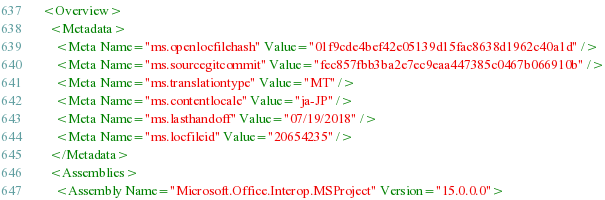<code> <loc_0><loc_0><loc_500><loc_500><_XML_><Overview>
  <Metadata>
    <Meta Name="ms.openlocfilehash" Value="01f9cde4bef42e05139d15fac8638d1962c40a1d" />
    <Meta Name="ms.sourcegitcommit" Value="fec857fbb3ba2e7ec9eaa447385c0467b066910b" />
    <Meta Name="ms.translationtype" Value="MT" />
    <Meta Name="ms.contentlocale" Value="ja-JP" />
    <Meta Name="ms.lasthandoff" Value="07/19/2018" />
    <Meta Name="ms.locfileid" Value="20654235" />
  </Metadata>
  <Assemblies>
    <Assembly Name="Microsoft.Office.Interop.MSProject" Version="15.0.0.0"></code> 